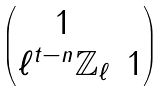<formula> <loc_0><loc_0><loc_500><loc_500>\begin{pmatrix} 1 & \\ \ell ^ { t - n } \mathbb { Z } _ { \ell } & 1 \end{pmatrix}</formula> 